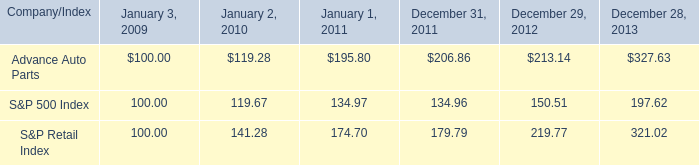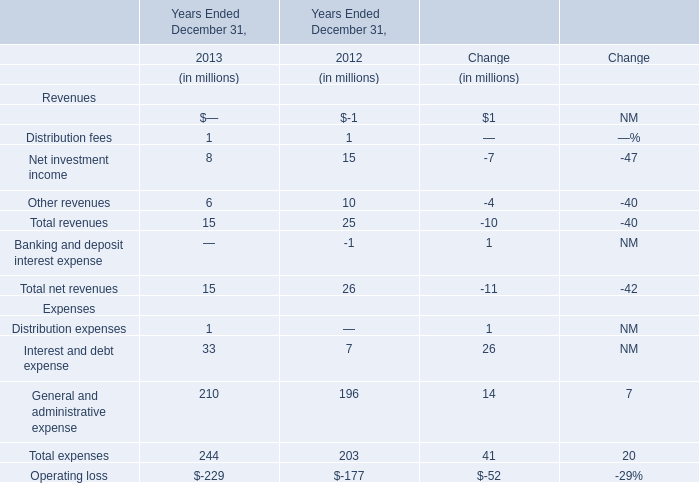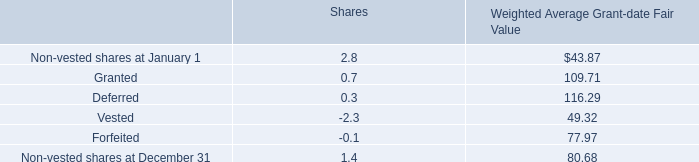from 2009 to 2012 , what percentage return did advance auto parts beat the overall market? 
Computations: ((213.14 - 100) - (150.51 - 100))
Answer: 62.63. 